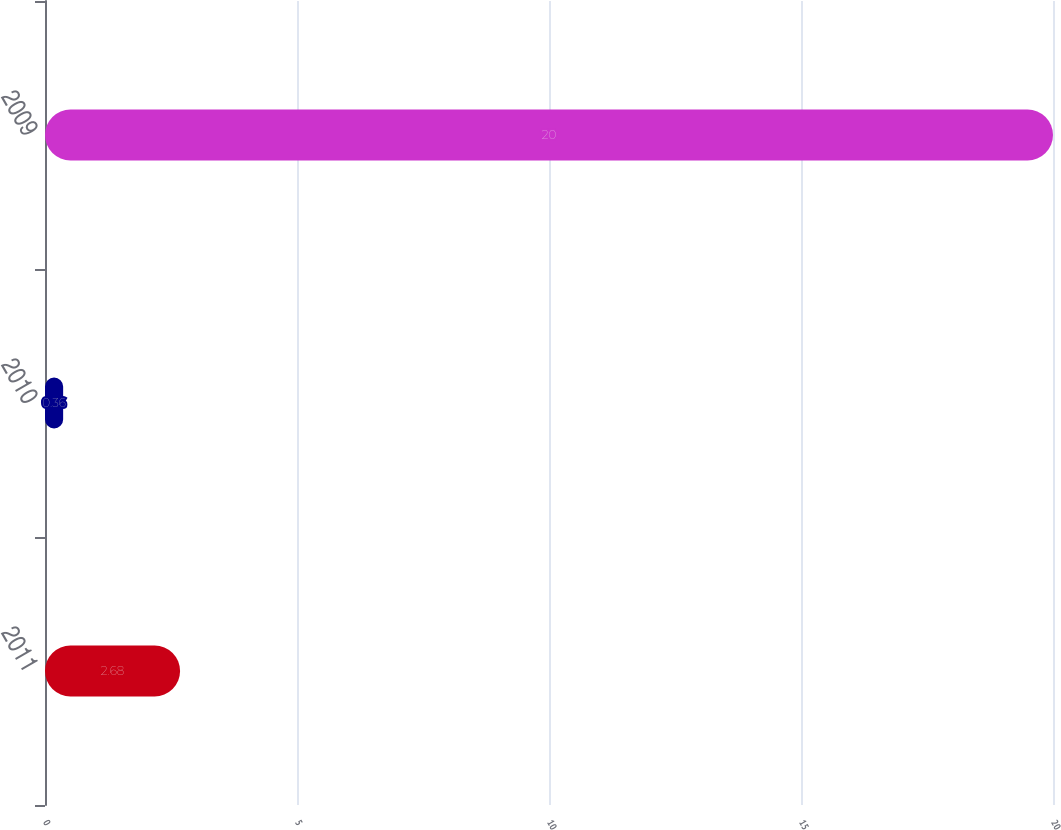<chart> <loc_0><loc_0><loc_500><loc_500><bar_chart><fcel>2011<fcel>2010<fcel>2009<nl><fcel>2.68<fcel>0.36<fcel>20<nl></chart> 